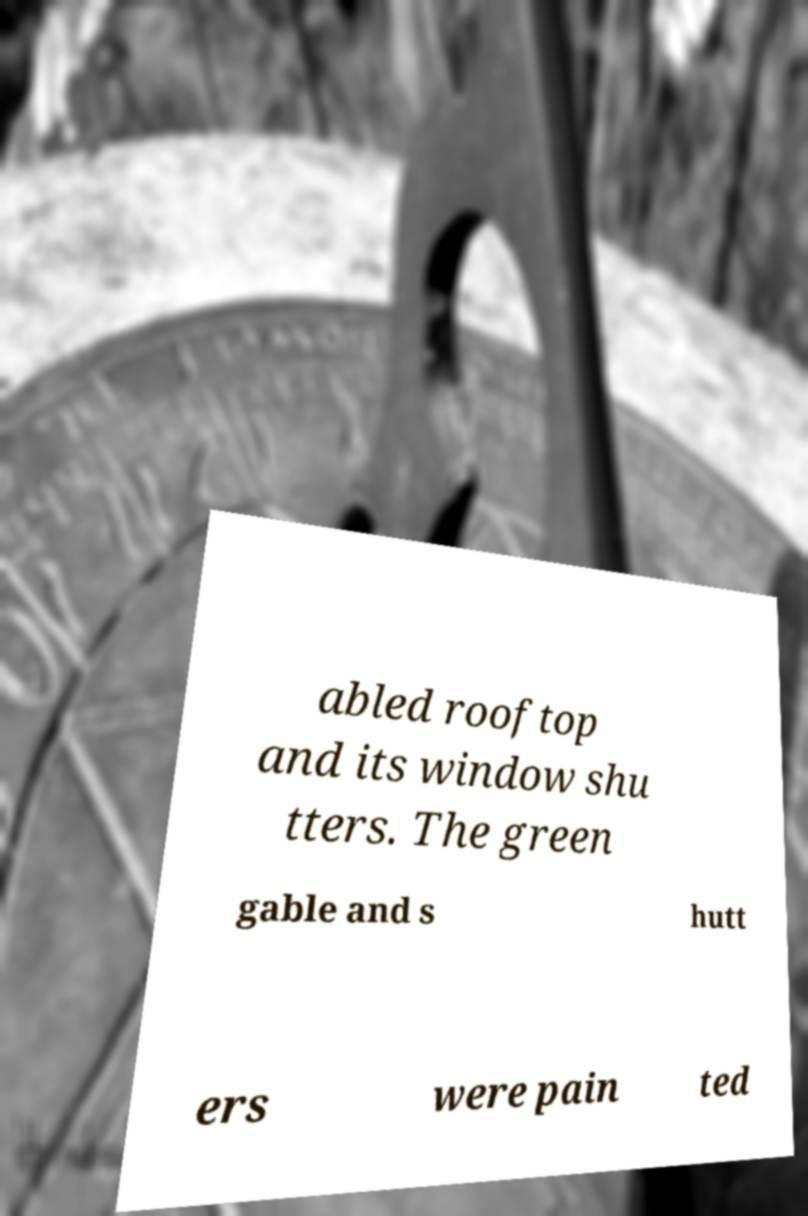Could you assist in decoding the text presented in this image and type it out clearly? abled rooftop and its window shu tters. The green gable and s hutt ers were pain ted 